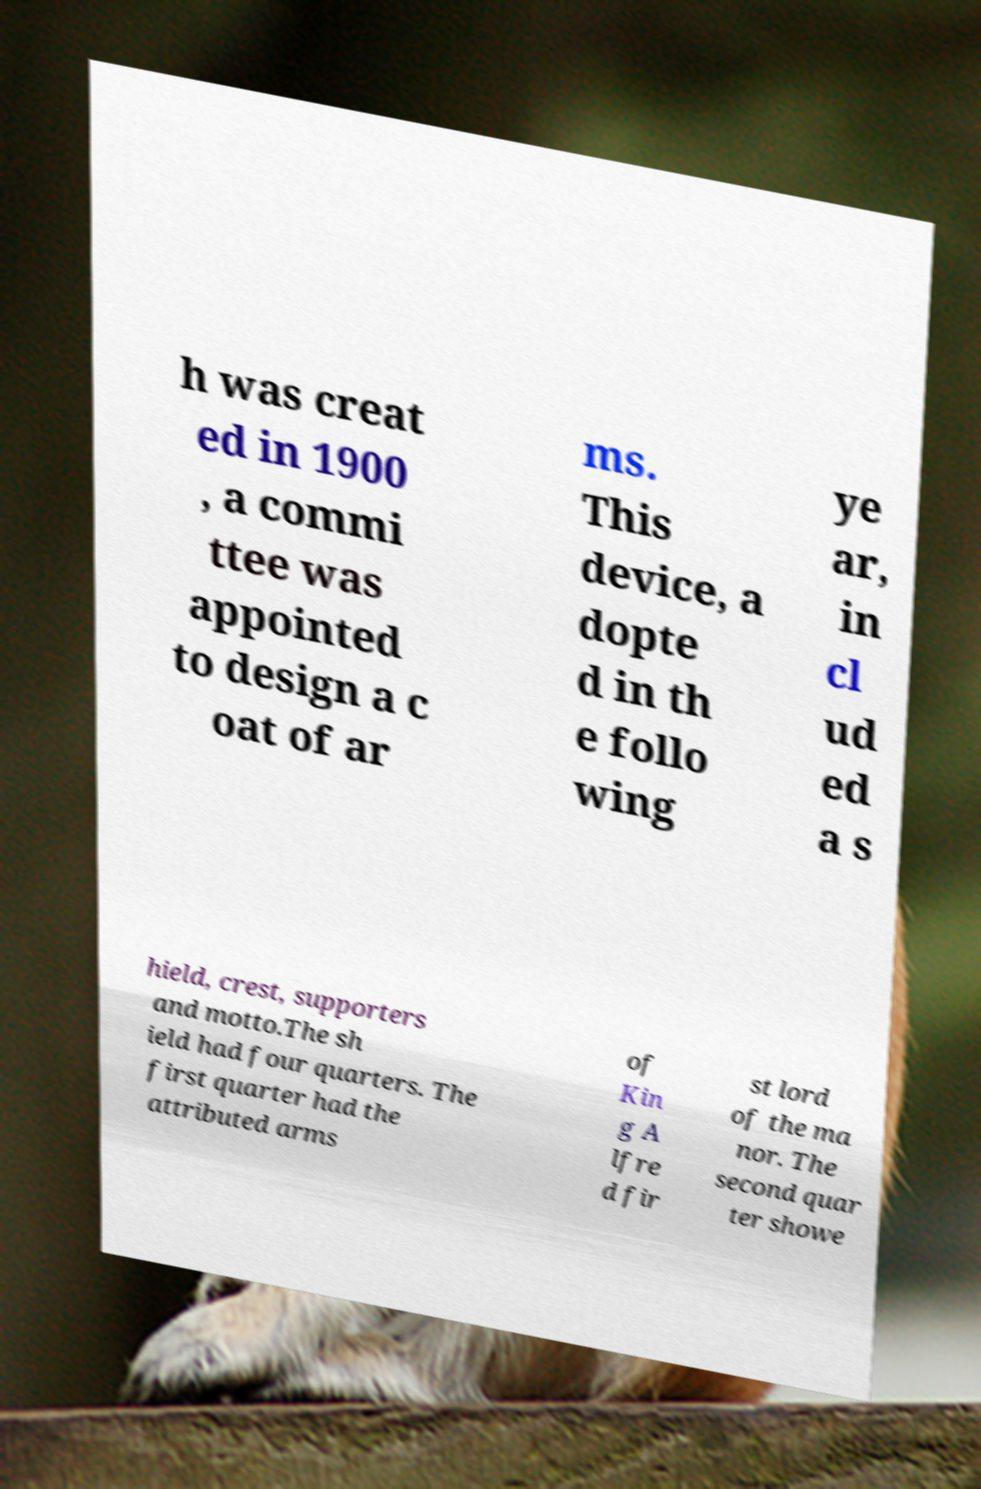Please read and relay the text visible in this image. What does it say? h was creat ed in 1900 , a commi ttee was appointed to design a c oat of ar ms. This device, a dopte d in th e follo wing ye ar, in cl ud ed a s hield, crest, supporters and motto.The sh ield had four quarters. The first quarter had the attributed arms of Kin g A lfre d fir st lord of the ma nor. The second quar ter showe 